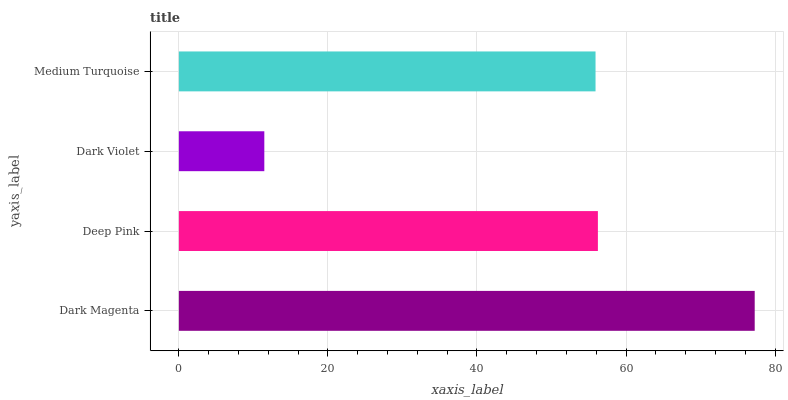Is Dark Violet the minimum?
Answer yes or no. Yes. Is Dark Magenta the maximum?
Answer yes or no. Yes. Is Deep Pink the minimum?
Answer yes or no. No. Is Deep Pink the maximum?
Answer yes or no. No. Is Dark Magenta greater than Deep Pink?
Answer yes or no. Yes. Is Deep Pink less than Dark Magenta?
Answer yes or no. Yes. Is Deep Pink greater than Dark Magenta?
Answer yes or no. No. Is Dark Magenta less than Deep Pink?
Answer yes or no. No. Is Deep Pink the high median?
Answer yes or no. Yes. Is Medium Turquoise the low median?
Answer yes or no. Yes. Is Dark Violet the high median?
Answer yes or no. No. Is Deep Pink the low median?
Answer yes or no. No. 